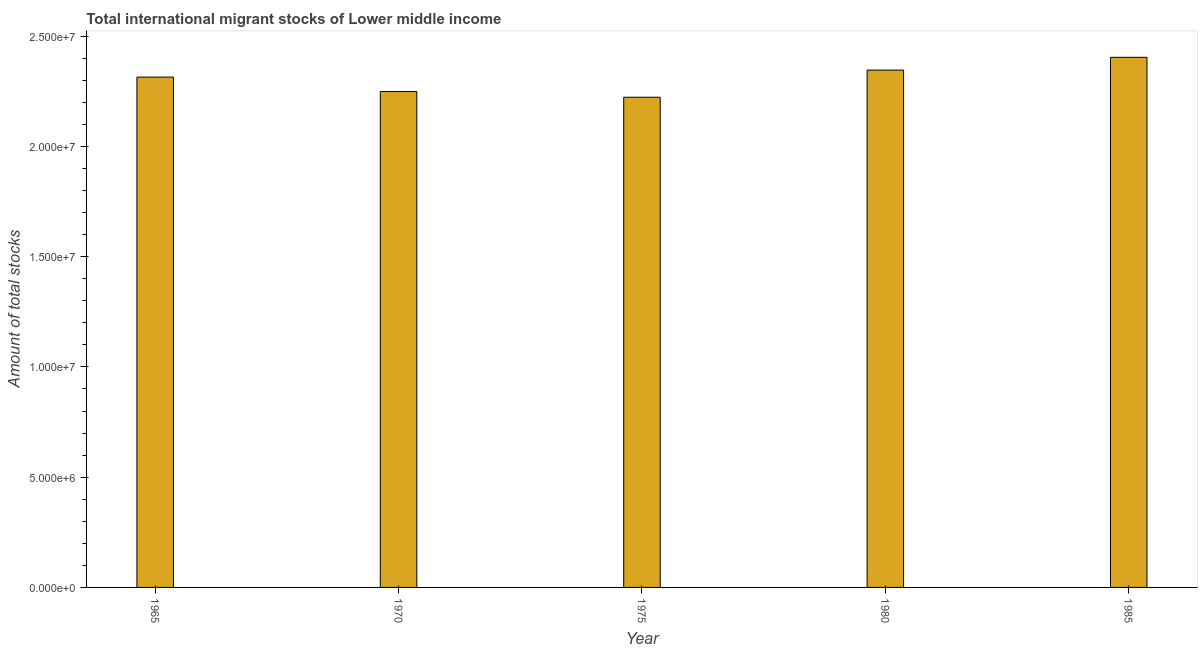Does the graph contain any zero values?
Your response must be concise. No. Does the graph contain grids?
Your response must be concise. No. What is the title of the graph?
Make the answer very short. Total international migrant stocks of Lower middle income. What is the label or title of the Y-axis?
Give a very brief answer. Amount of total stocks. What is the total number of international migrant stock in 1985?
Your answer should be very brief. 2.40e+07. Across all years, what is the maximum total number of international migrant stock?
Your answer should be compact. 2.40e+07. Across all years, what is the minimum total number of international migrant stock?
Offer a terse response. 2.22e+07. In which year was the total number of international migrant stock minimum?
Your answer should be compact. 1975. What is the sum of the total number of international migrant stock?
Offer a terse response. 1.15e+08. What is the difference between the total number of international migrant stock in 1975 and 1985?
Provide a succinct answer. -1.81e+06. What is the average total number of international migrant stock per year?
Your answer should be compact. 2.31e+07. What is the median total number of international migrant stock?
Your answer should be compact. 2.31e+07. In how many years, is the total number of international migrant stock greater than 20000000 ?
Keep it short and to the point. 5. What is the ratio of the total number of international migrant stock in 1965 to that in 1980?
Keep it short and to the point. 0.99. Is the difference between the total number of international migrant stock in 1965 and 1980 greater than the difference between any two years?
Keep it short and to the point. No. What is the difference between the highest and the second highest total number of international migrant stock?
Keep it short and to the point. 5.79e+05. Is the sum of the total number of international migrant stock in 1970 and 1985 greater than the maximum total number of international migrant stock across all years?
Provide a succinct answer. Yes. What is the difference between the highest and the lowest total number of international migrant stock?
Make the answer very short. 1.81e+06. Are all the bars in the graph horizontal?
Make the answer very short. No. How many years are there in the graph?
Provide a short and direct response. 5. What is the Amount of total stocks of 1965?
Your answer should be compact. 2.31e+07. What is the Amount of total stocks of 1970?
Your answer should be very brief. 2.25e+07. What is the Amount of total stocks of 1975?
Your answer should be compact. 2.22e+07. What is the Amount of total stocks in 1980?
Make the answer very short. 2.35e+07. What is the Amount of total stocks of 1985?
Your response must be concise. 2.40e+07. What is the difference between the Amount of total stocks in 1965 and 1970?
Make the answer very short. 6.54e+05. What is the difference between the Amount of total stocks in 1965 and 1975?
Make the answer very short. 9.13e+05. What is the difference between the Amount of total stocks in 1965 and 1980?
Ensure brevity in your answer.  -3.18e+05. What is the difference between the Amount of total stocks in 1965 and 1985?
Offer a very short reply. -8.97e+05. What is the difference between the Amount of total stocks in 1970 and 1975?
Your answer should be very brief. 2.59e+05. What is the difference between the Amount of total stocks in 1970 and 1980?
Your answer should be very brief. -9.72e+05. What is the difference between the Amount of total stocks in 1970 and 1985?
Provide a succinct answer. -1.55e+06. What is the difference between the Amount of total stocks in 1975 and 1980?
Your response must be concise. -1.23e+06. What is the difference between the Amount of total stocks in 1975 and 1985?
Provide a succinct answer. -1.81e+06. What is the difference between the Amount of total stocks in 1980 and 1985?
Give a very brief answer. -5.79e+05. What is the ratio of the Amount of total stocks in 1965 to that in 1970?
Offer a terse response. 1.03. What is the ratio of the Amount of total stocks in 1965 to that in 1975?
Make the answer very short. 1.04. What is the ratio of the Amount of total stocks in 1965 to that in 1985?
Keep it short and to the point. 0.96. What is the ratio of the Amount of total stocks in 1970 to that in 1975?
Give a very brief answer. 1.01. What is the ratio of the Amount of total stocks in 1970 to that in 1980?
Keep it short and to the point. 0.96. What is the ratio of the Amount of total stocks in 1970 to that in 1985?
Your response must be concise. 0.94. What is the ratio of the Amount of total stocks in 1975 to that in 1980?
Offer a very short reply. 0.95. What is the ratio of the Amount of total stocks in 1975 to that in 1985?
Give a very brief answer. 0.93. 